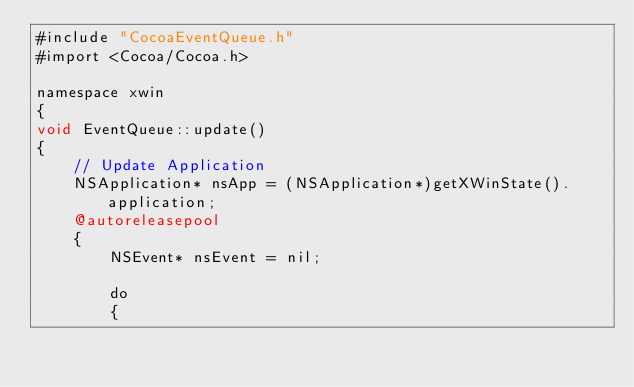Convert code to text. <code><loc_0><loc_0><loc_500><loc_500><_ObjectiveC_>#include "CocoaEventQueue.h"
#import <Cocoa/Cocoa.h>

namespace xwin
{
void EventQueue::update()
{
    // Update Application
    NSApplication* nsApp = (NSApplication*)getXWinState().application;
    @autoreleasepool
    {
        NSEvent* nsEvent = nil;
        
        do
        {</code> 